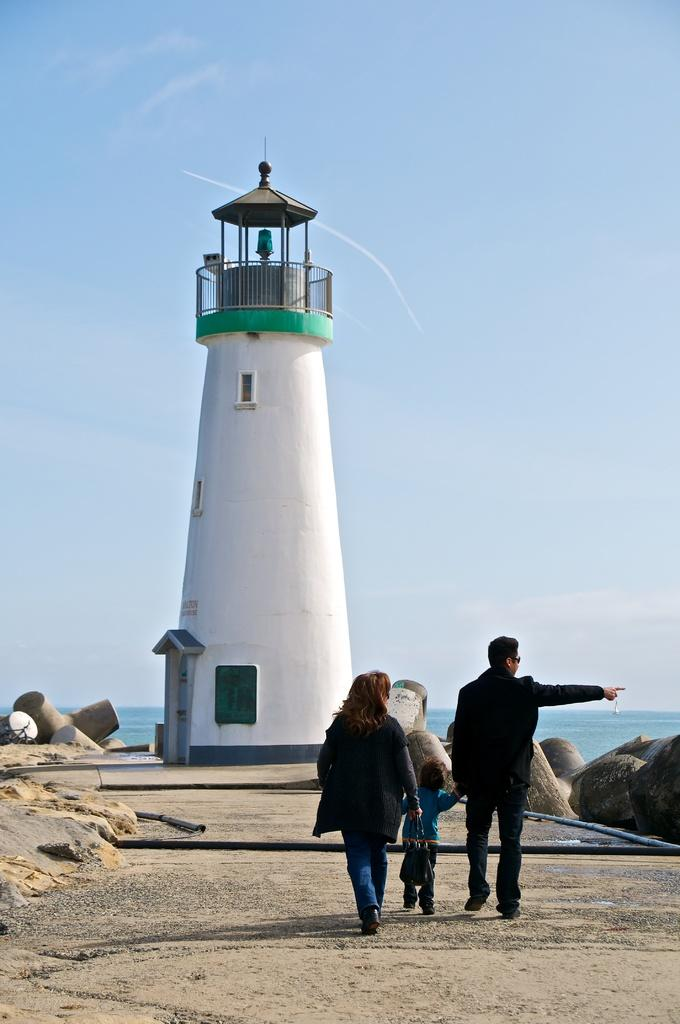What is the main structure in the image? There is a lighthouse in the image. How many people are present in the image? There are three persons in the image. What can be seen on the ground in the image? There is a path in the image. What type of natural features are present in the image? There are rocks in the image. What is visible in the background of the image? Water and a clear sky are visible in the background of the image. What is the value of the baseball bat in the image? There is no baseball bat present in the image. What type of development can be seen in the image? The image does not show any development or construction; it features a lighthouse, people, a path, rocks, water, and a clear sky. 